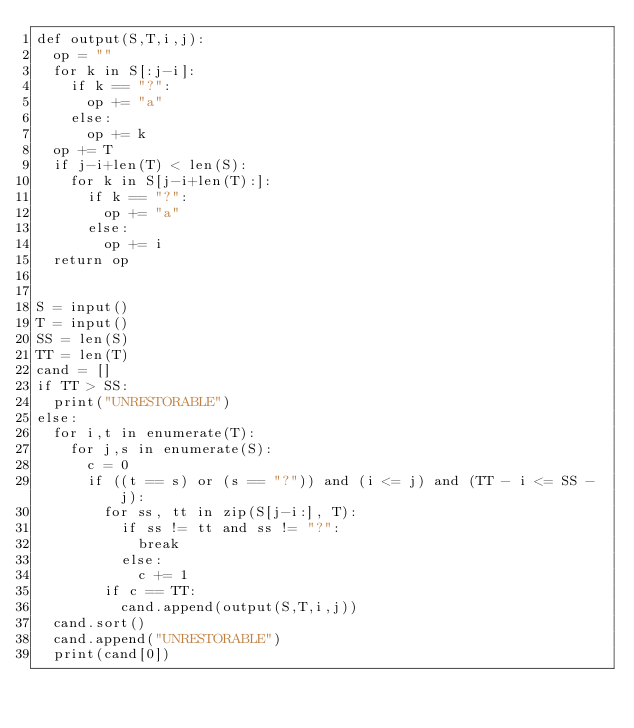Convert code to text. <code><loc_0><loc_0><loc_500><loc_500><_Python_>def output(S,T,i,j):
  op = ""
  for k in S[:j-i]:
    if k == "?":
      op += "a"
    else:
      op += k
  op += T
  if j-i+len(T) < len(S):
    for k in S[j-i+len(T):]:
      if k == "?":
        op += "a"
      else:
        op += i
  return op


S = input()
T = input()
SS = len(S)
TT = len(T)
cand = []
if TT > SS:
  print("UNRESTORABLE")
else:
  for i,t in enumerate(T):
    for j,s in enumerate(S):
      c = 0
      if ((t == s) or (s == "?")) and (i <= j) and (TT - i <= SS - j):
        for ss, tt in zip(S[j-i:], T):
          if ss != tt and ss != "?":
            break
          else:
            c += 1
        if c == TT:
          cand.append(output(S,T,i,j))
  cand.sort()
  cand.append("UNRESTORABLE")
  print(cand[0])</code> 